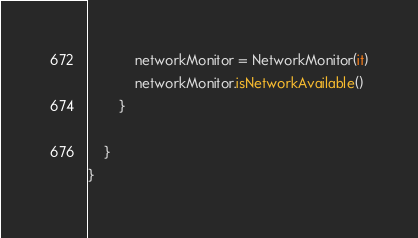Convert code to text. <code><loc_0><loc_0><loc_500><loc_500><_Kotlin_>            networkMonitor = NetworkMonitor(it)
            networkMonitor.isNetworkAvailable()
        }

    }
}</code> 